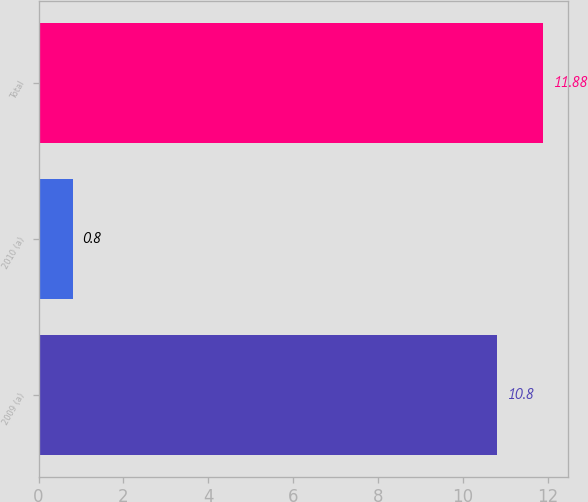Convert chart. <chart><loc_0><loc_0><loc_500><loc_500><bar_chart><fcel>2009 (a)<fcel>2010 (a)<fcel>Total<nl><fcel>10.8<fcel>0.8<fcel>11.88<nl></chart> 